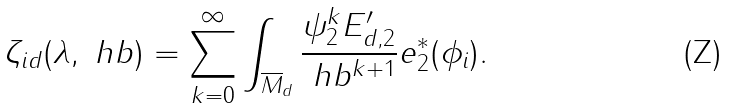Convert formula to latex. <formula><loc_0><loc_0><loc_500><loc_500>\zeta _ { i d } ( \lambda , \ h b ) = \sum _ { k = 0 } ^ { \infty } \int _ { \overline { M } _ { d } } \frac { \psi _ { 2 } ^ { k } E ^ { \prime } _ { d , 2 } } { \ h b ^ { k + 1 } } e _ { 2 } ^ { * } ( \phi _ { i } ) .</formula> 